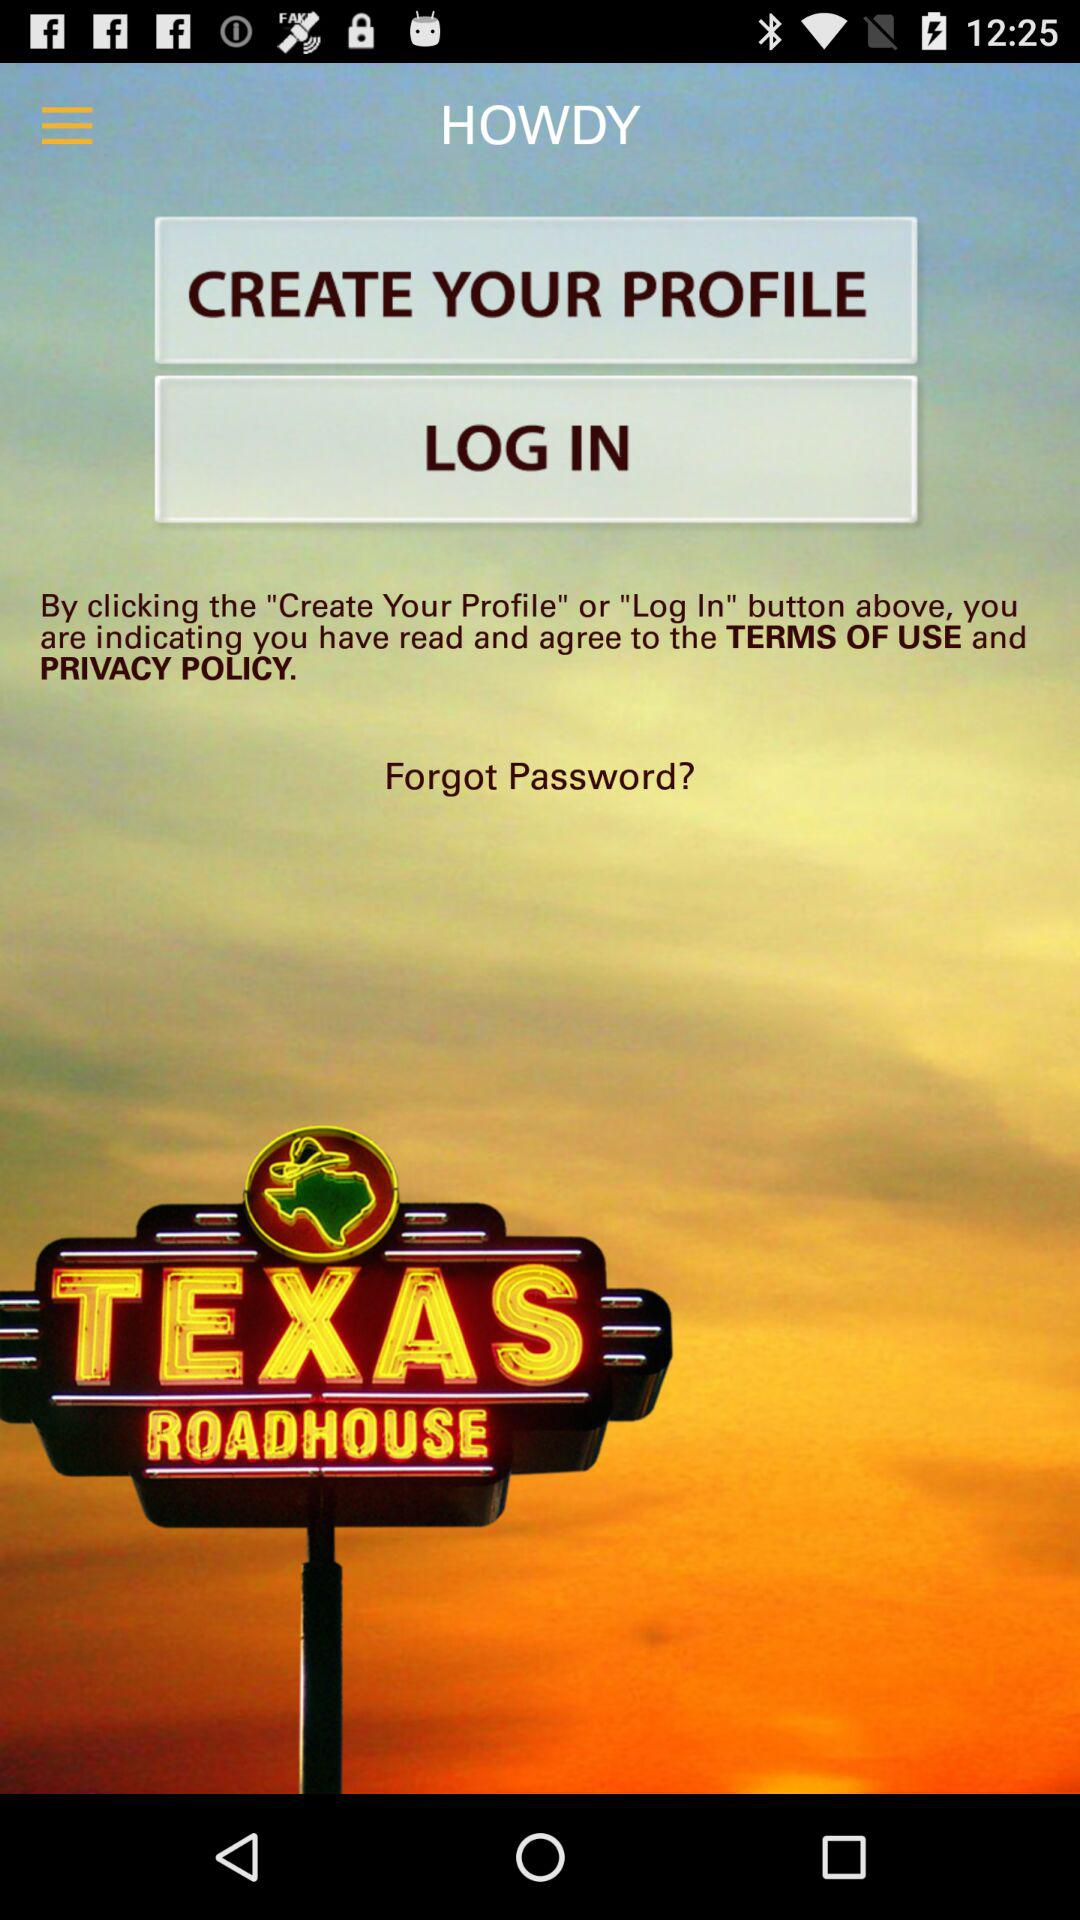What is the name of the application? The application name is Texas Roadhouse. 